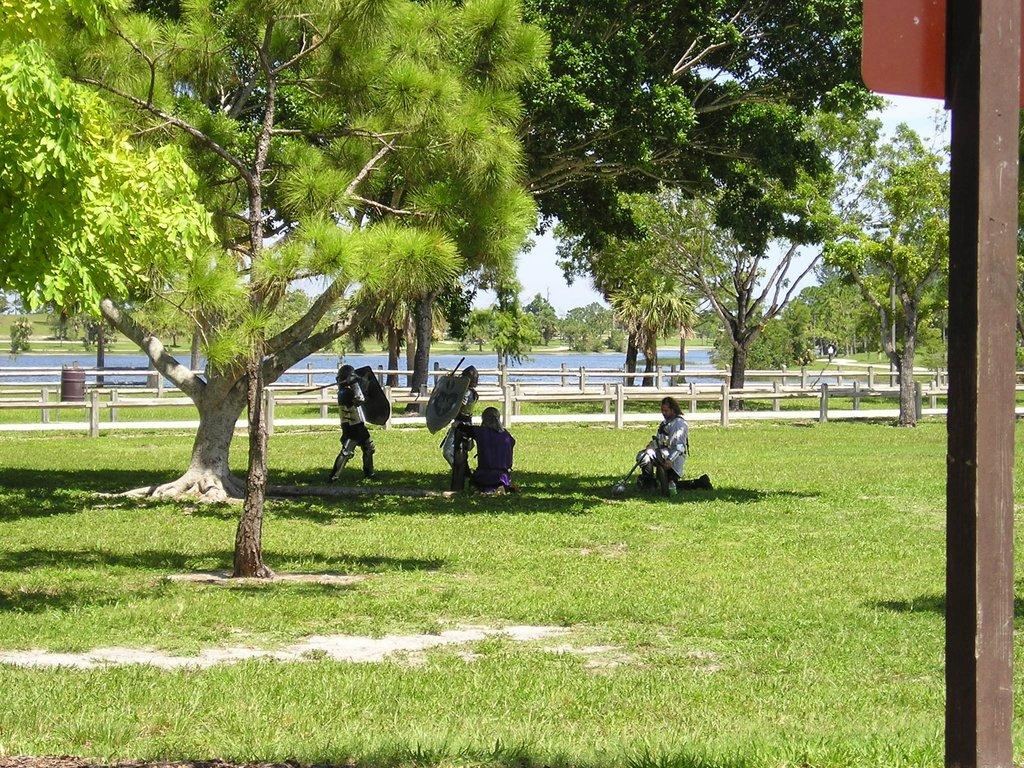What type of vegetation is present in the image? There are trees and grass in the image. What are the people in the image doing? The people are sitting on the grass in the image. What type of music can be heard coming from the train in the image? There is no train present in the image, so it is not possible to determine what, if any, music might be heard. 